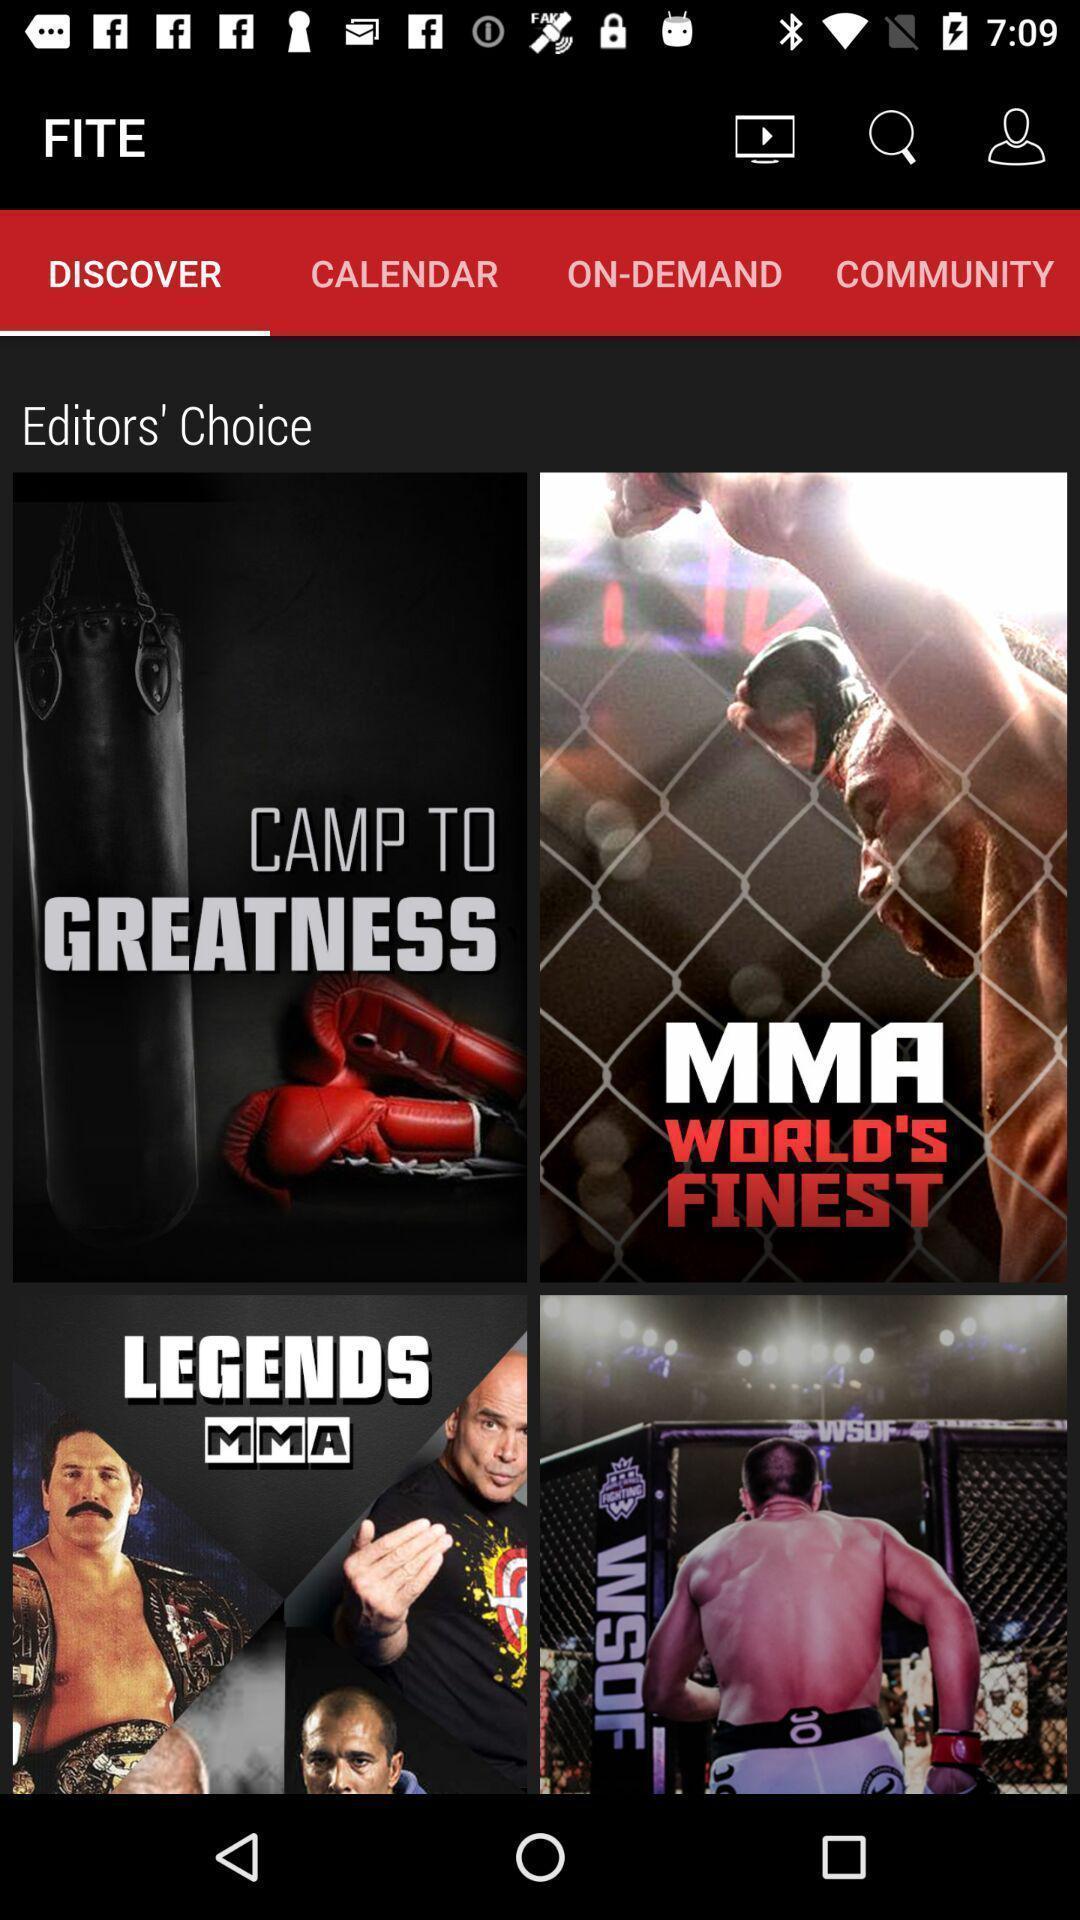Provide a textual representation of this image. Various kinds of images with quotations in the application. 